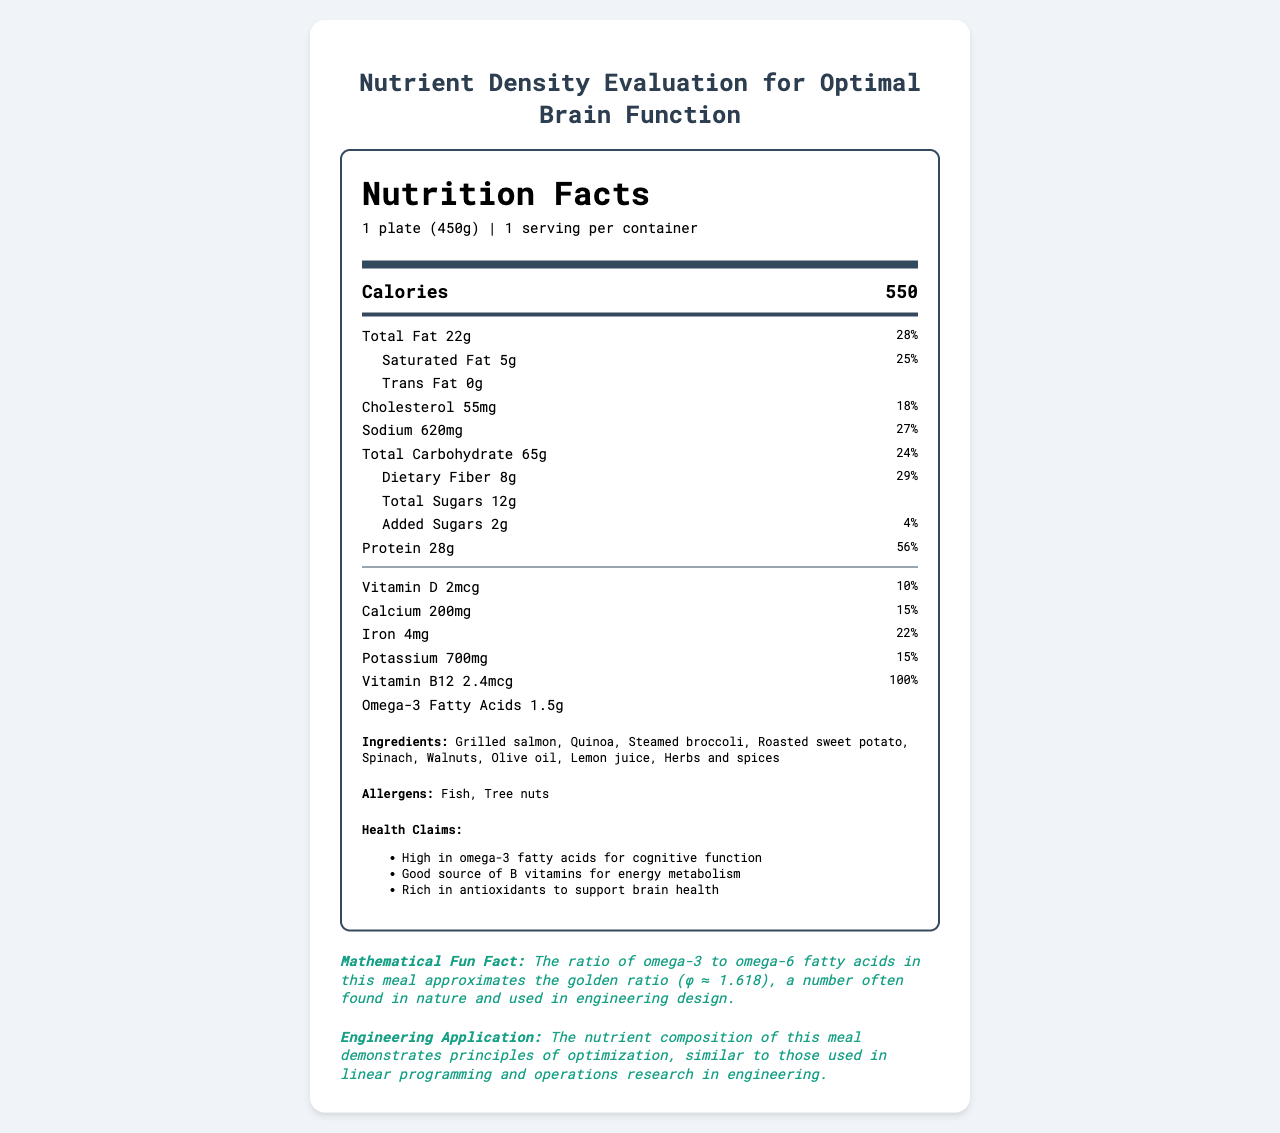what is the serving size of Brain Boost Cafeteria Platter? The serving size is listed at the top of the document under the product name.
Answer: 1 plate (450g) how many calories are in one serving of this meal? The calories are specified in a highlighted large-font area beneath the nutrition title.
Answer: 550 how much total fat is in one serving, and what percentage of the daily value does this represent? This information is found in the section listing total fat along with its daily value percentage.
Answer: 22g, 28% what types of fat are present in the Brain Boost Cafeteria Platter? The types of fat listed are saturated fat and trans fat under the total fat section.
Answer: Saturated fat and trans fat does the meal contain any B vitamins? It contains Vitamin B12, as listed in the nutrition facts section.
Answer: Yes how many grams of dietary fiber are in one serving? The amount of dietary fiber is provided in the nutrition facts section.
Answer: 8g what allergen warnings are included with the meal? The allergen information is listed at the bottom of the document.
Answer: Fish, Tree nuts describe the health benefits of consuming this meal. These health claims are listed towards the bottom of the document under health claims.
Answer: The meal is high in omega-3 fatty acids for cognitive function, a good source of B vitamins for energy metabolism, and rich in antioxidants to support brain health. which of the following ingredients are included in the meal? A. Grilled chicken B. Quinoa C. Steamed broccoli D. Roasted sweet potato The ingredients list includes Quinoa, Steamed broccoli, and Roasted sweet potato but not Grilled chicken.
Answer: B, C, D how much protein is in one serving of the meal, and what percentage of the daily value does this amount represent? A. 14g, 28% B. 20g, 40% C. 28g, 56% D. 32g, 64% The document specifies that the meal contains 28g of protein, which is 56% of the daily value.
Answer: C is the amount of Omega-3 Fatty Acids given in the nutrition facts? The amount is listed as 1.5g in the nutrition facts section.
Answer: Yes what is the main idea of the document? The document includes detailed nutritional facts, ingredients, allergens, health claims, a mathematical fun fact, and an engineering application relevant to optimizing nutrient composition.
Answer: It provides the nutritional information and health benefits of the Brain Boost Cafeteria Platter, focusing on its nutrient density for optimal brain function. what is the main source of carbohydrates in the Brain Boost Cafeteria Platter? While the document lists the amount of carbohydrates, it does not specify which ingredient is the main source of carbohydrates.
Answer: Not enough information 